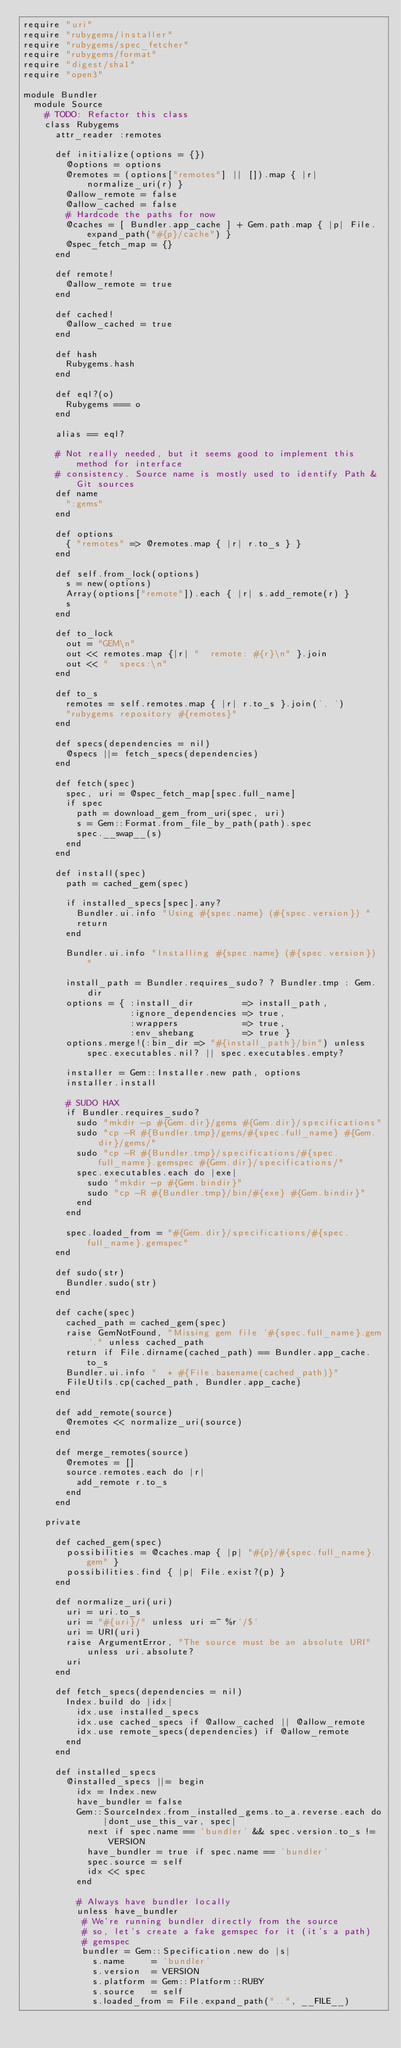<code> <loc_0><loc_0><loc_500><loc_500><_Ruby_>require "uri"
require "rubygems/installer"
require "rubygems/spec_fetcher"
require "rubygems/format"
require "digest/sha1"
require "open3"

module Bundler
  module Source
    # TODO: Refactor this class
    class Rubygems
      attr_reader :remotes

      def initialize(options = {})
        @options = options
        @remotes = (options["remotes"] || []).map { |r| normalize_uri(r) }
        @allow_remote = false
        @allow_cached = false
        # Hardcode the paths for now
        @caches = [ Bundler.app_cache ] + Gem.path.map { |p| File.expand_path("#{p}/cache") }
        @spec_fetch_map = {}
      end

      def remote!
        @allow_remote = true
      end

      def cached!
        @allow_cached = true
      end

      def hash
        Rubygems.hash
      end

      def eql?(o)
        Rubygems === o
      end

      alias == eql?

      # Not really needed, but it seems good to implement this method for interface
      # consistency. Source name is mostly used to identify Path & Git sources
      def name
        ":gems"
      end

      def options
        { "remotes" => @remotes.map { |r| r.to_s } }
      end

      def self.from_lock(options)
        s = new(options)
        Array(options["remote"]).each { |r| s.add_remote(r) }
        s
      end

      def to_lock
        out = "GEM\n"
        out << remotes.map {|r| "  remote: #{r}\n" }.join
        out << "  specs:\n"
      end

      def to_s
        remotes = self.remotes.map { |r| r.to_s }.join(', ')
        "rubygems repository #{remotes}"
      end

      def specs(dependencies = nil)
        @specs ||= fetch_specs(dependencies)
      end

      def fetch(spec)
        spec, uri = @spec_fetch_map[spec.full_name]
        if spec
          path = download_gem_from_uri(spec, uri)
          s = Gem::Format.from_file_by_path(path).spec
          spec.__swap__(s)
        end
      end

      def install(spec)
        path = cached_gem(spec)

        if installed_specs[spec].any?
          Bundler.ui.info "Using #{spec.name} (#{spec.version}) "
          return
        end

        Bundler.ui.info "Installing #{spec.name} (#{spec.version}) "

        install_path = Bundler.requires_sudo? ? Bundler.tmp : Gem.dir
        options = { :install_dir         => install_path,
                    :ignore_dependencies => true,
                    :wrappers            => true,
                    :env_shebang         => true }
        options.merge!(:bin_dir => "#{install_path}/bin") unless spec.executables.nil? || spec.executables.empty?

        installer = Gem::Installer.new path, options
        installer.install

        # SUDO HAX
        if Bundler.requires_sudo?
          sudo "mkdir -p #{Gem.dir}/gems #{Gem.dir}/specifications"
          sudo "cp -R #{Bundler.tmp}/gems/#{spec.full_name} #{Gem.dir}/gems/"
          sudo "cp -R #{Bundler.tmp}/specifications/#{spec.full_name}.gemspec #{Gem.dir}/specifications/"
          spec.executables.each do |exe|
            sudo "mkdir -p #{Gem.bindir}"
            sudo "cp -R #{Bundler.tmp}/bin/#{exe} #{Gem.bindir}"
          end
        end

        spec.loaded_from = "#{Gem.dir}/specifications/#{spec.full_name}.gemspec"
      end

      def sudo(str)
        Bundler.sudo(str)
      end

      def cache(spec)
        cached_path = cached_gem(spec)
        raise GemNotFound, "Missing gem file '#{spec.full_name}.gem'." unless cached_path
        return if File.dirname(cached_path) == Bundler.app_cache.to_s
        Bundler.ui.info "  * #{File.basename(cached_path)}"
        FileUtils.cp(cached_path, Bundler.app_cache)
      end

      def add_remote(source)
        @remotes << normalize_uri(source)
      end

      def merge_remotes(source)
        @remotes = []
        source.remotes.each do |r|
          add_remote r.to_s
        end
      end

    private

      def cached_gem(spec)
        possibilities = @caches.map { |p| "#{p}/#{spec.full_name}.gem" }
        possibilities.find { |p| File.exist?(p) }
      end

      def normalize_uri(uri)
        uri = uri.to_s
        uri = "#{uri}/" unless uri =~ %r'/$'
        uri = URI(uri)
        raise ArgumentError, "The source must be an absolute URI" unless uri.absolute?
        uri
      end

      def fetch_specs(dependencies = nil)
        Index.build do |idx|
          idx.use installed_specs
          idx.use cached_specs if @allow_cached || @allow_remote
          idx.use remote_specs(dependencies) if @allow_remote
        end
      end

      def installed_specs
        @installed_specs ||= begin
          idx = Index.new
          have_bundler = false
          Gem::SourceIndex.from_installed_gems.to_a.reverse.each do |dont_use_this_var, spec|
            next if spec.name == 'bundler' && spec.version.to_s != VERSION
            have_bundler = true if spec.name == 'bundler'
            spec.source = self
            idx << spec
          end

          # Always have bundler locally
          unless have_bundler
           # We're running bundler directly from the source
           # so, let's create a fake gemspec for it (it's a path)
           # gemspec
           bundler = Gem::Specification.new do |s|
             s.name     = 'bundler'
             s.version  = VERSION
             s.platform = Gem::Platform::RUBY
             s.source   = self
             s.loaded_from = File.expand_path("..", __FILE__)</code> 